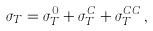<formula> <loc_0><loc_0><loc_500><loc_500>\sigma _ { T } = \sigma _ { T } ^ { 0 } + \sigma _ { T } ^ { C } + \sigma _ { T } ^ { C C } \, ,</formula> 